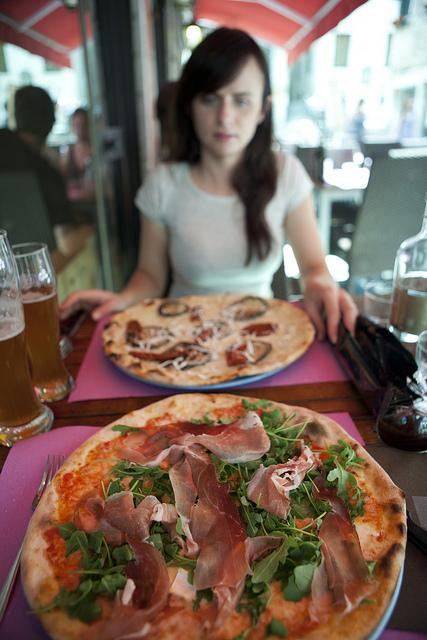Does this person drink wine?
Answer briefly. No. What color is the plate?
Short answer required. Blue. Has any of the pizza been eaten yet?
Give a very brief answer. No. Is she a pizza baker?
Concise answer only. No. What protects the girl's face from the sun?
Give a very brief answer. Awning. Is this person a vegetarian?
Concise answer only. No. Is she happy to be eating?
Give a very brief answer. No. What color is the woman's shirt?
Give a very brief answer. White. Do these people have the same meal in front of them?
Write a very short answer. No. Is the woman smiling?
Give a very brief answer. No. Are these both vegetarian pizzas?
Give a very brief answer. No. What beverage is in the clear cup?
Write a very short answer. Beer. Is she happy?
Concise answer only. No. 